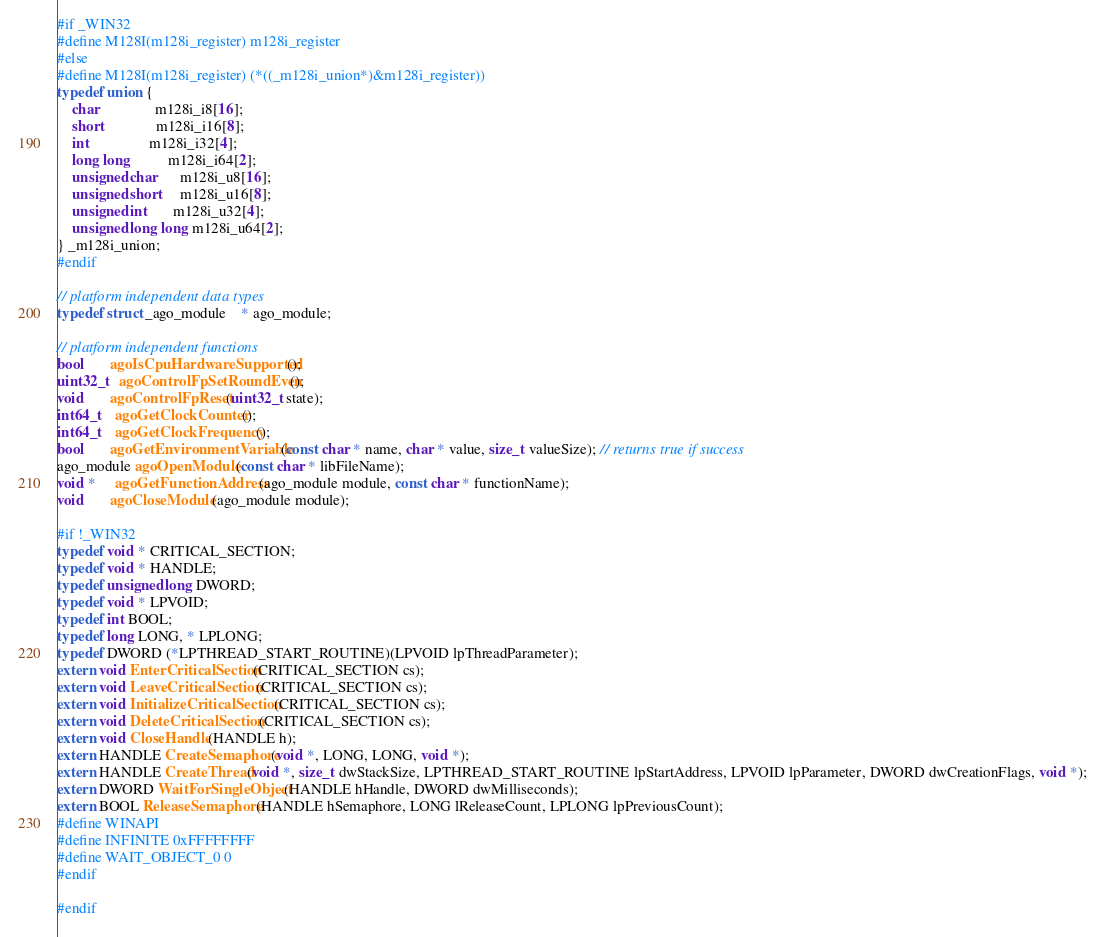<code> <loc_0><loc_0><loc_500><loc_500><_C_>#if _WIN32
#define M128I(m128i_register) m128i_register
#else
#define M128I(m128i_register) (*((_m128i_union*)&m128i_register))
typedef union {
	char               m128i_i8[16];
	short              m128i_i16[8];
	int                m128i_i32[4];
	long long          m128i_i64[2];
	unsigned char      m128i_u8[16];
	unsigned short     m128i_u16[8];
	unsigned int       m128i_u32[4];
	unsigned long long m128i_u64[2];
} _m128i_union;
#endif

// platform independent data types
typedef struct _ago_module    * ago_module;

// platform independent functions
bool       agoIsCpuHardwareSupported();
uint32_t   agoControlFpSetRoundEven();
void       agoControlFpReset(uint32_t state);
int64_t    agoGetClockCounter();
int64_t    agoGetClockFrequency();
bool       agoGetEnvironmentVariable(const char * name, char * value, size_t valueSize); // returns true if success
ago_module agoOpenModule(const char * libFileName);
void *     agoGetFunctionAddress(ago_module module, const char * functionName);
void       agoCloseModule(ago_module module);

#if !_WIN32
typedef void * CRITICAL_SECTION;
typedef void * HANDLE;
typedef unsigned long DWORD;
typedef void * LPVOID;
typedef int BOOL;
typedef long LONG, * LPLONG;
typedef DWORD (*LPTHREAD_START_ROUTINE)(LPVOID lpThreadParameter);
extern void EnterCriticalSection(CRITICAL_SECTION cs);
extern void LeaveCriticalSection(CRITICAL_SECTION cs);
extern void InitializeCriticalSection(CRITICAL_SECTION cs);
extern void DeleteCriticalSection(CRITICAL_SECTION cs);
extern void CloseHandle(HANDLE h);
extern HANDLE CreateSemaphore(void *, LONG, LONG, void *);
extern HANDLE CreateThread(void *, size_t dwStackSize, LPTHREAD_START_ROUTINE lpStartAddress, LPVOID lpParameter, DWORD dwCreationFlags, void *);
extern DWORD WaitForSingleObject(HANDLE hHandle, DWORD dwMilliseconds);
extern BOOL ReleaseSemaphore(HANDLE hSemaphore, LONG lReleaseCount, LPLONG lpPreviousCount);
#define WINAPI
#define INFINITE 0xFFFFFFFF
#define WAIT_OBJECT_0 0
#endif

#endif
</code> 